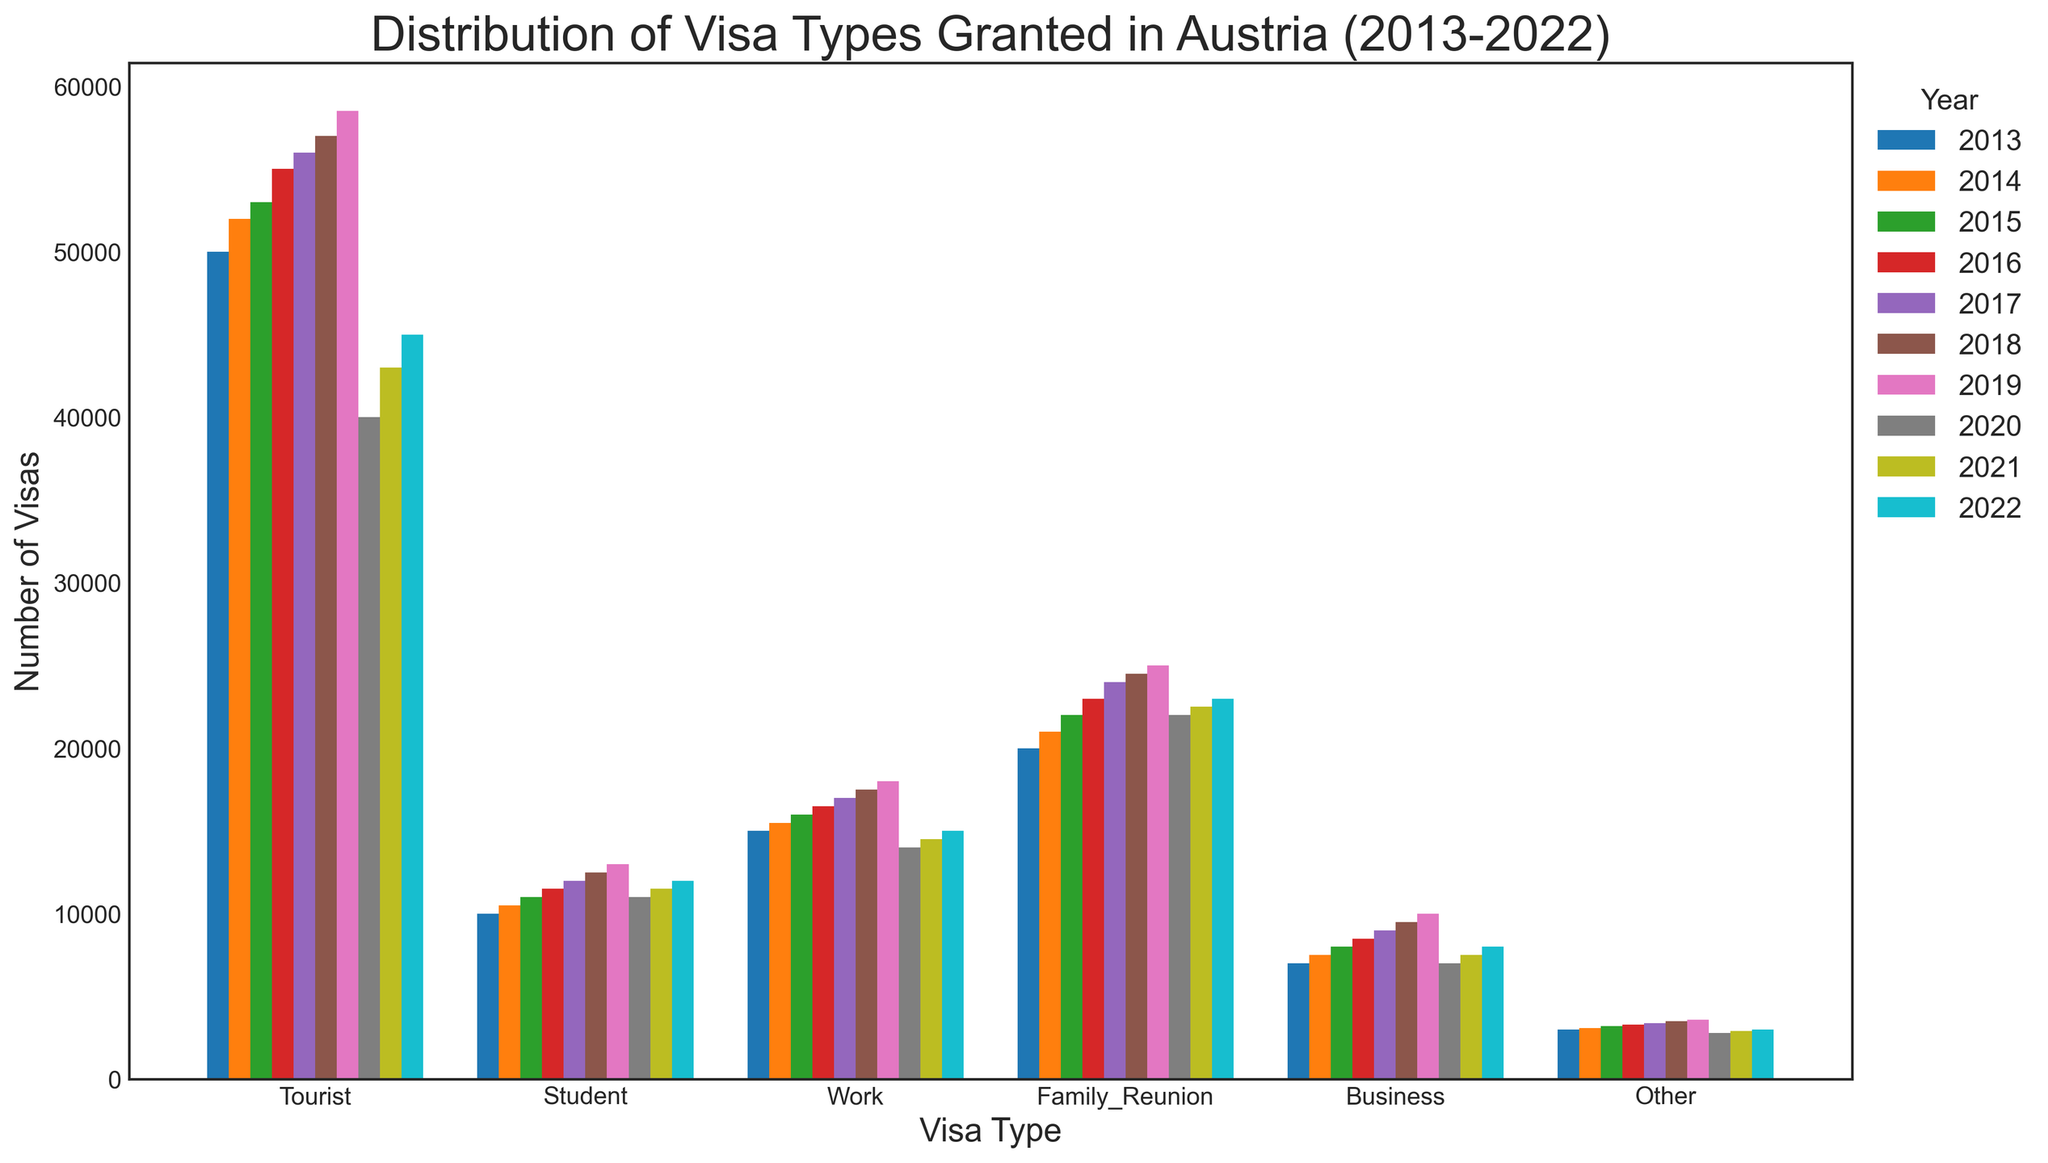What's the overall trend for Tourist visas from 2013 to 2022? To see the trend, observe the height of the bars representing Tourist visas from 2013 to 2022. The height increases steadily from 2013 to 2019, then drops in 2020, and slightly recovers in 2021 and 2022.
Answer: Increasing until 2019, then decreasing Which visa type had the least variation in the number of visas granted from 2013 to 2022? Compare the height of the bars for each visa type across all years. The "Other" visa type shows the least variation, as its bar heights remain relatively constant.
Answer: Other In which year was the number of Family Reunion visas the highest? Look at the series of bars corresponding to Family Reunion visas and determine which bar is the tallest. In this case, 2022 has the highest bar for Family Reunion visas.
Answer: 2022 How did the number of Student visas change from 2015 to 2020? Observe the height of the bars for Student visas for the years 2015 to 2020. The bar height increases steadily from 2015 to 2019 and decreases in 2020.
Answer: Increased then decreased What's the difference in the number of Work visas between 2013 and 2019? Observe the height of the bars for Work visas in 2013 and 2019. Subtract the height for 2013 from that for 2019. The numbers are 15000 in 2013 and 18000 in 2019 giving a difference of 3000.
Answer: 3000 Which visa type had the most significant drop in visas granted in 2020? Find the visa type with the most noticeable difference in bar height between 2019 and 2020. Tourist visas had the largest drop from 58500 in 2019 to 40000 in 2020.
Answer: Tourist What is the average number of Business visas granted from 2013 to 2022? Sum the values of the Business visas for each year from 2013 to 2022, then divide by the number of years (10). The sum is 90000, and the average is 9000.
Answer: 9000 Which visa type consistently had more than 20,000 visas granted each year? Check each visa type and see which one has a bar height consistently above 20,000 for all years. The Family Reunion visa type consistently exceeds 20,000 each year.
Answer: Family_Reunion 